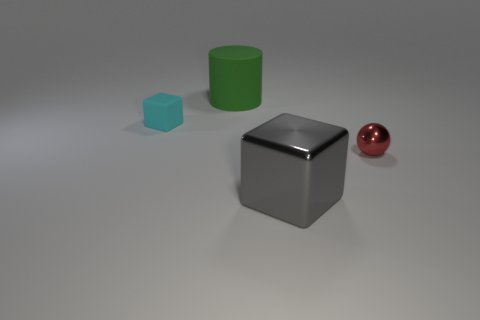Subtract all gray blocks. How many blocks are left? 1 Add 1 red metal objects. How many objects exist? 5 Subtract 0 yellow cubes. How many objects are left? 4 Subtract all cylinders. How many objects are left? 3 Subtract 1 cubes. How many cubes are left? 1 Subtract all brown balls. Subtract all brown blocks. How many balls are left? 1 Subtract all red blocks. How many brown cylinders are left? 0 Subtract all small rubber blocks. Subtract all red metal objects. How many objects are left? 2 Add 3 metallic balls. How many metallic balls are left? 4 Add 3 big purple matte spheres. How many big purple matte spheres exist? 3 